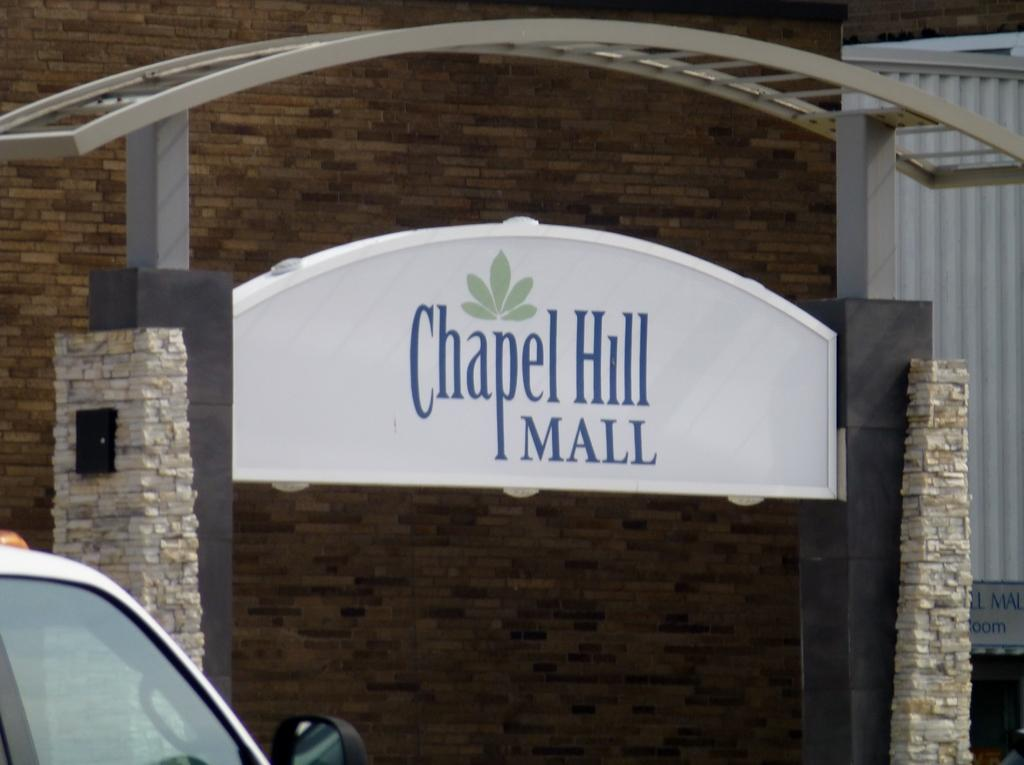What structure is present in the image? There is an arch in the image. What is written or displayed on the arch? There is a board with text on the arch. What type of vehicle can be seen in the image? There is a vehicle at the bottom left of the image. What type of wall can be seen in the background of the image? There is a wall with bricks in the background of the image. How many brothers are depicted playing with plants in the image? There are no brothers or plants present in the image. What type of arithmetic problem is being solved on the board with text? There is no arithmetic problem visible on the board with text; it only contains written or displayed information. 